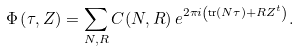Convert formula to latex. <formula><loc_0><loc_0><loc_500><loc_500>\Phi \left ( \tau , Z \right ) = \sum _ { N , R } C ( N , R ) \, e ^ { 2 \pi i \left ( \text {tr} ( N \tau ) + R Z ^ { t } \right ) } .</formula> 